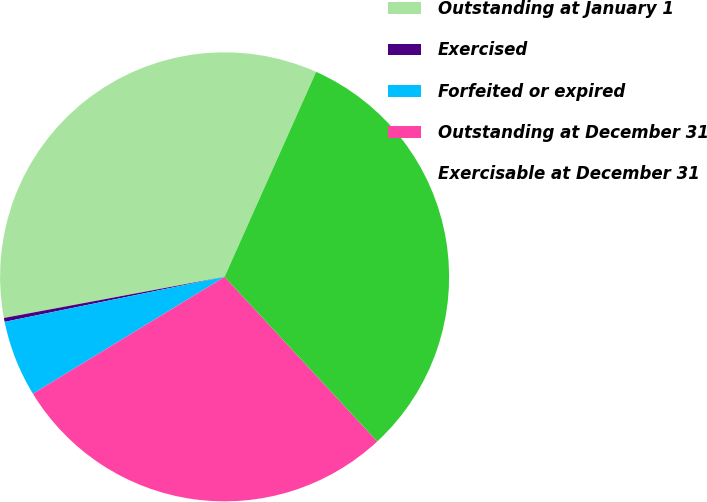Convert chart. <chart><loc_0><loc_0><loc_500><loc_500><pie_chart><fcel>Outstanding at January 1<fcel>Exercised<fcel>Forfeited or expired<fcel>Outstanding at December 31<fcel>Exercisable at December 31<nl><fcel>34.62%<fcel>0.28%<fcel>5.5%<fcel>28.19%<fcel>31.41%<nl></chart> 